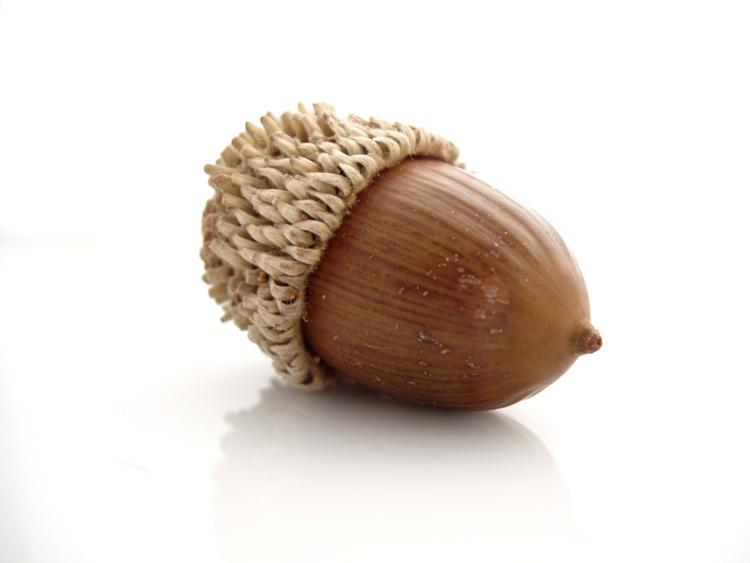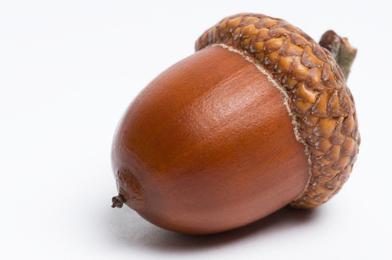The first image is the image on the left, the second image is the image on the right. For the images shown, is this caption "One picture shows at least three acorns next to each other." true? Answer yes or no. No. The first image is the image on the left, the second image is the image on the right. Considering the images on both sides, is "There are more items in the right image than in the left image." valid? Answer yes or no. No. 